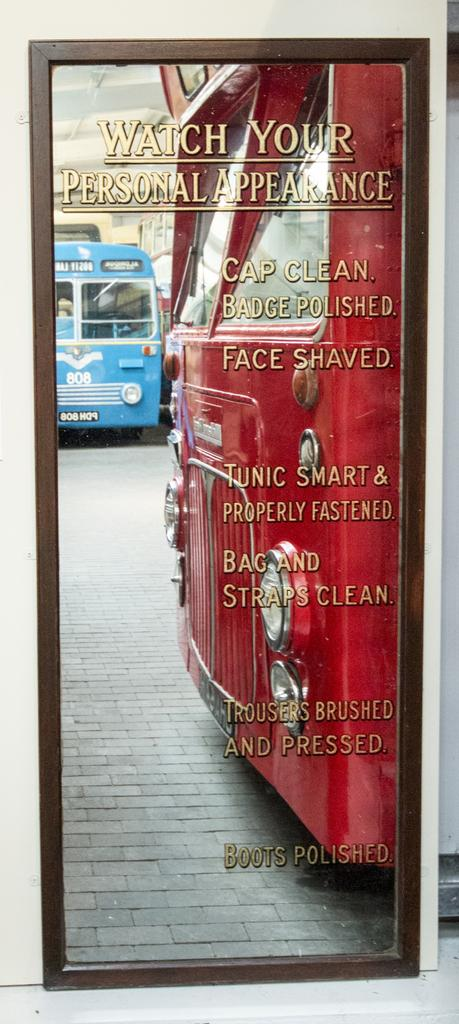What object is present in the image that can reflect images? There is a mirror in the image. What is depicted on the mirror? Two buses are parked on the mirror. Is there any text visible on the mirror? Yes, there is text visible on the mirror. What type of island can be seen in the background of the mirror? There is no island visible in the image, as the mirror only shows two buses parked on it. 